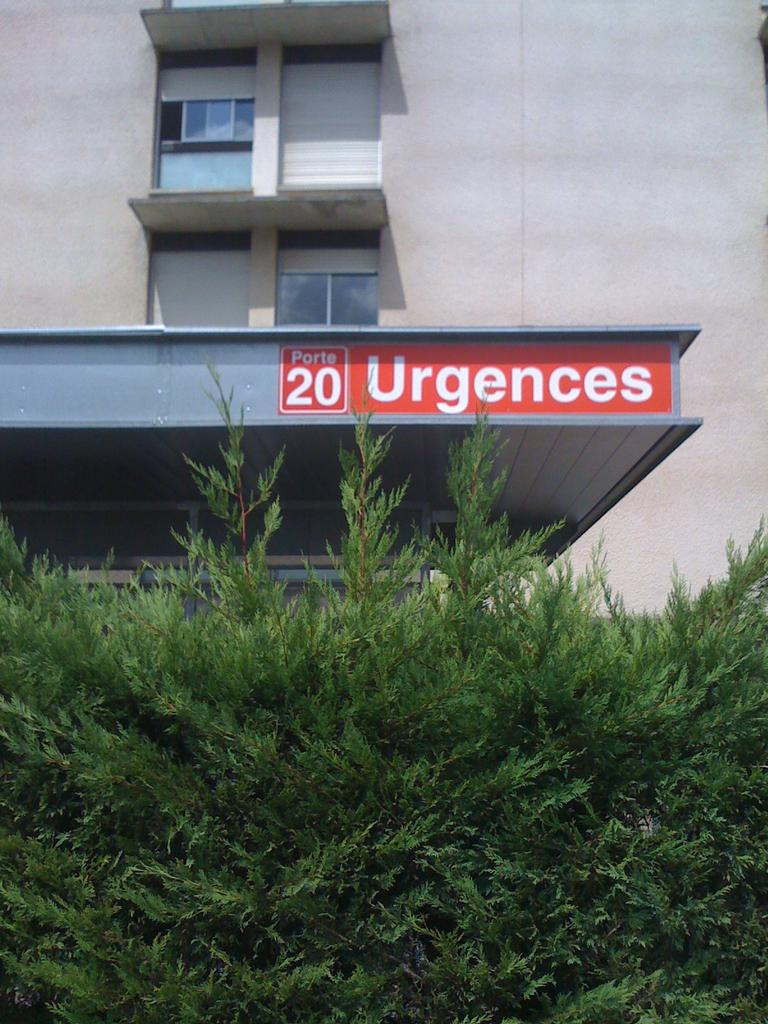What type of living organisms are at the bottom of the image? There are plants at the bottom of the image. What type of structure can be seen in the background of the image? There is a building in the background of the image. How many eggs can be seen in the image? There are no eggs present in the image. What type of facial expression can be seen on the building in the image? There is no face or facial expression present on the building in the image. 